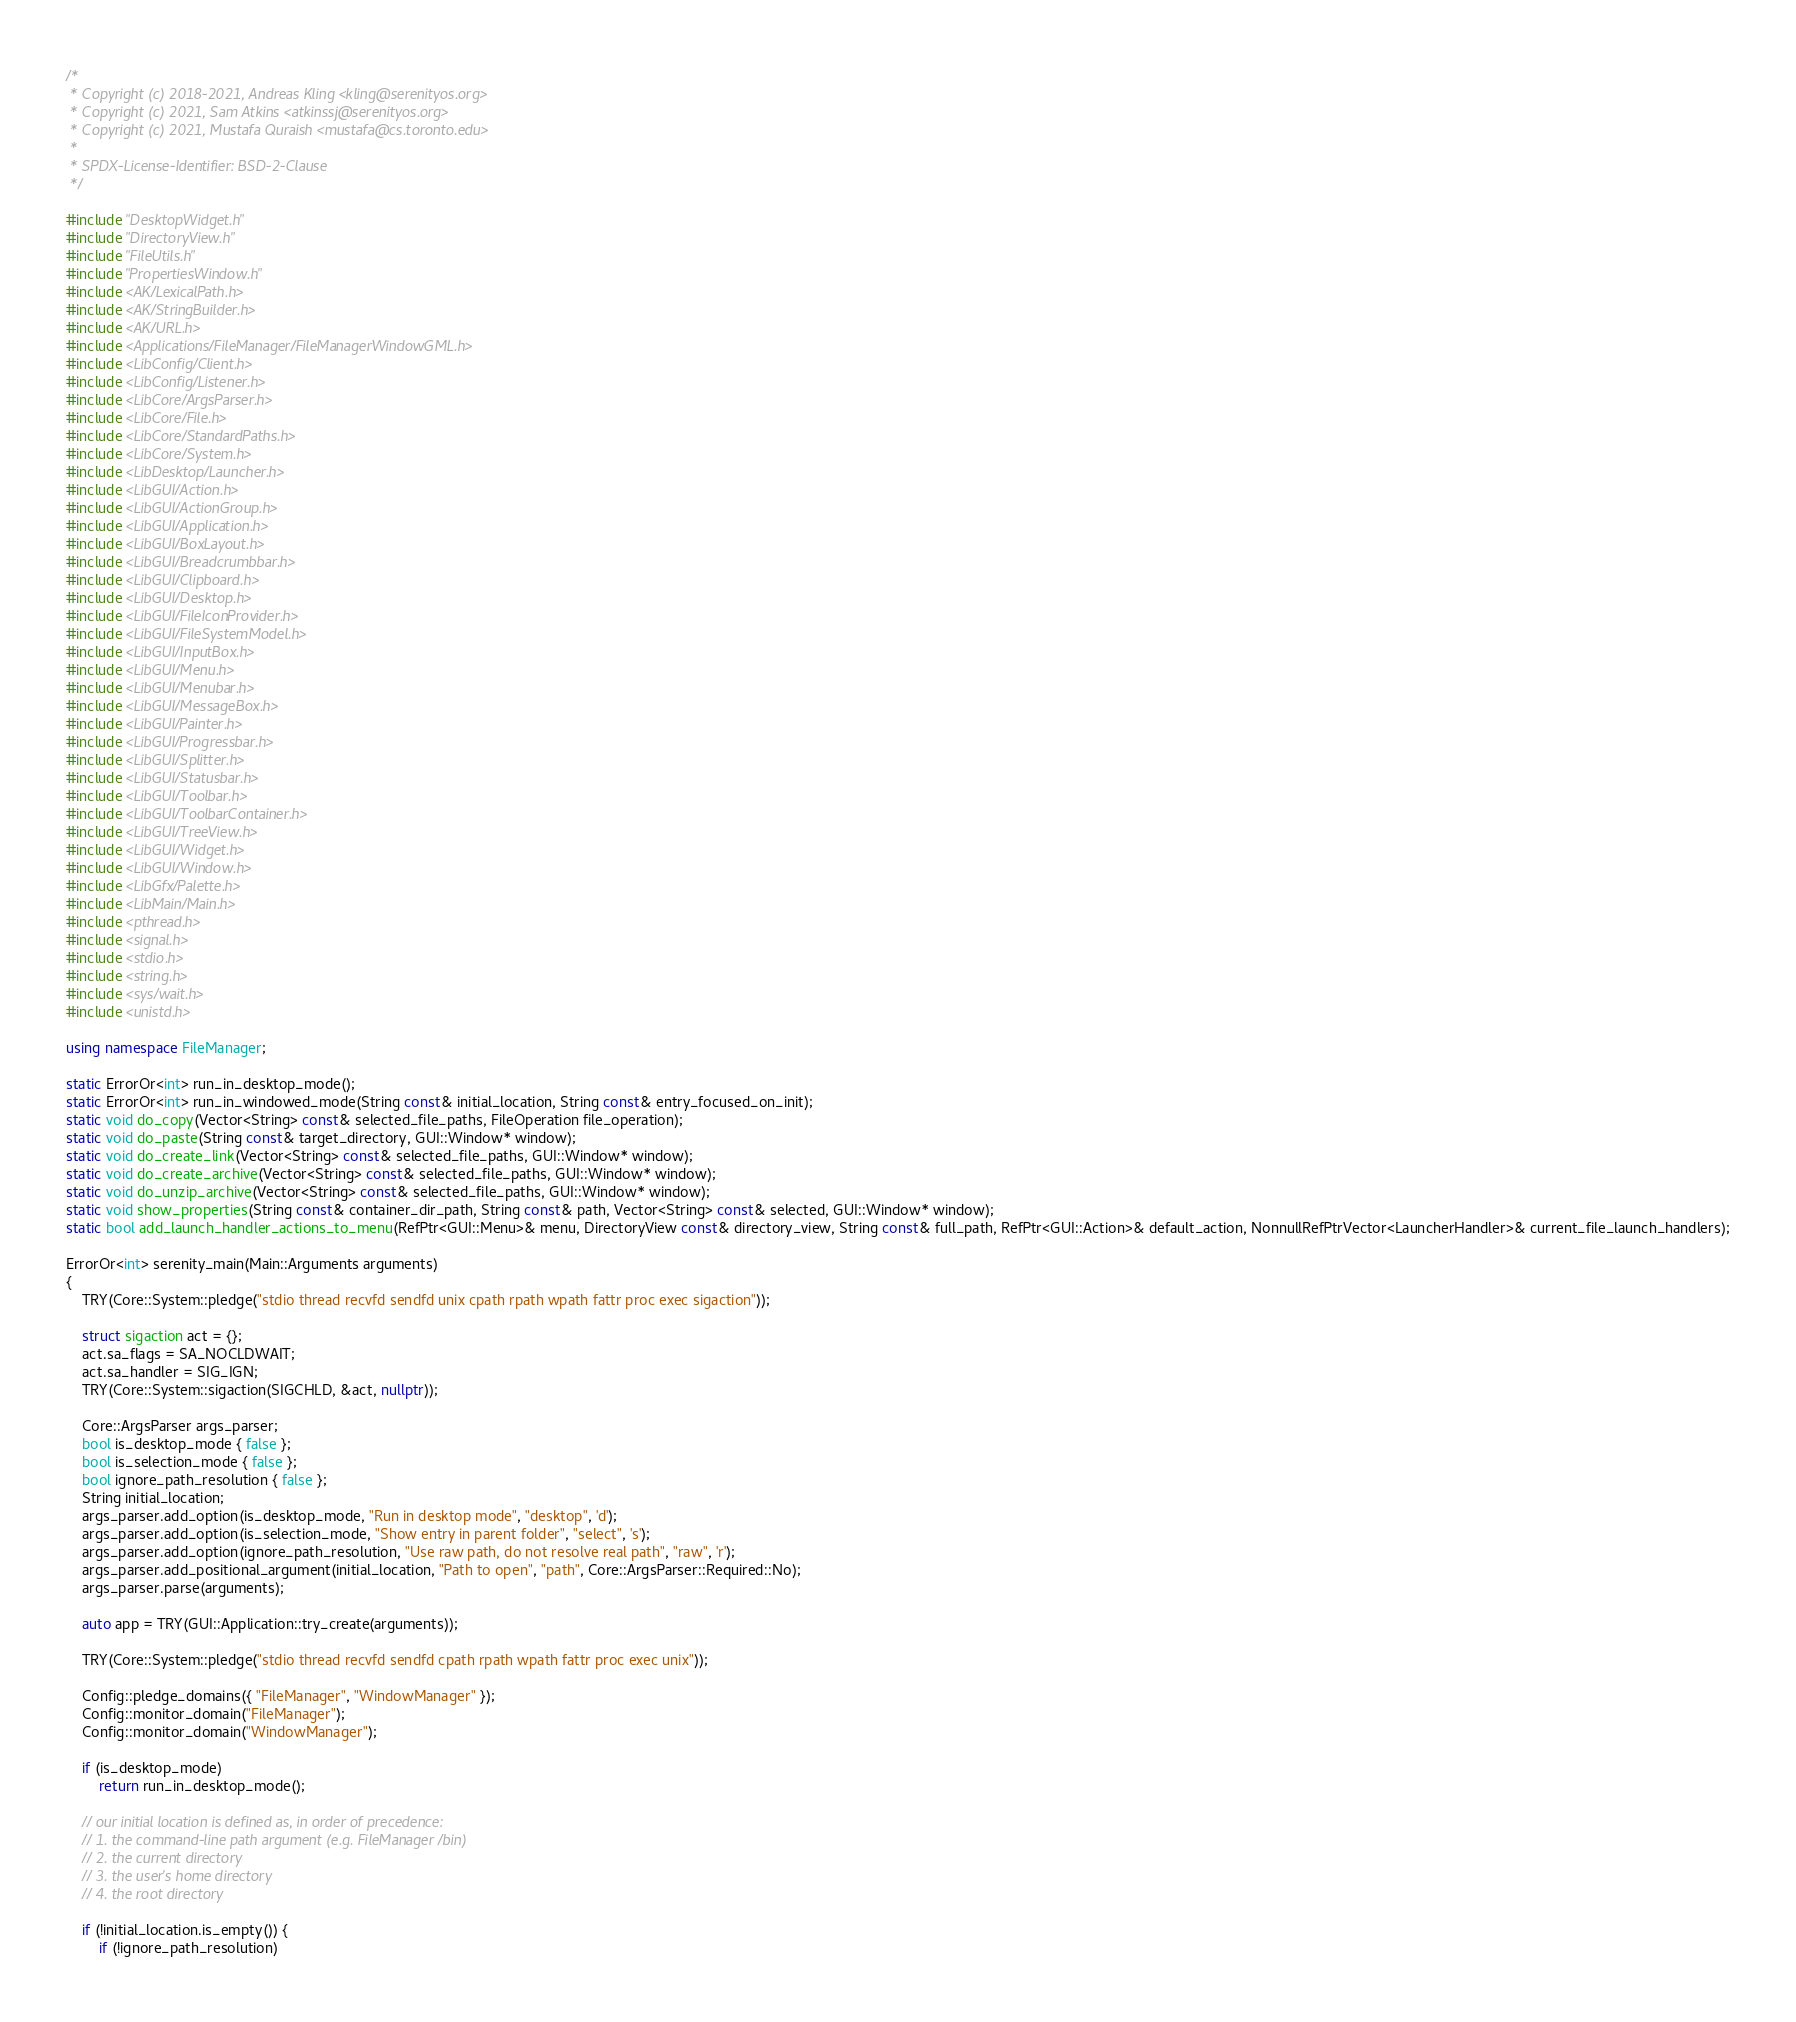Convert code to text. <code><loc_0><loc_0><loc_500><loc_500><_C++_>/*
 * Copyright (c) 2018-2021, Andreas Kling <kling@serenityos.org>
 * Copyright (c) 2021, Sam Atkins <atkinssj@serenityos.org>
 * Copyright (c) 2021, Mustafa Quraish <mustafa@cs.toronto.edu>
 *
 * SPDX-License-Identifier: BSD-2-Clause
 */

#include "DesktopWidget.h"
#include "DirectoryView.h"
#include "FileUtils.h"
#include "PropertiesWindow.h"
#include <AK/LexicalPath.h>
#include <AK/StringBuilder.h>
#include <AK/URL.h>
#include <Applications/FileManager/FileManagerWindowGML.h>
#include <LibConfig/Client.h>
#include <LibConfig/Listener.h>
#include <LibCore/ArgsParser.h>
#include <LibCore/File.h>
#include <LibCore/StandardPaths.h>
#include <LibCore/System.h>
#include <LibDesktop/Launcher.h>
#include <LibGUI/Action.h>
#include <LibGUI/ActionGroup.h>
#include <LibGUI/Application.h>
#include <LibGUI/BoxLayout.h>
#include <LibGUI/Breadcrumbbar.h>
#include <LibGUI/Clipboard.h>
#include <LibGUI/Desktop.h>
#include <LibGUI/FileIconProvider.h>
#include <LibGUI/FileSystemModel.h>
#include <LibGUI/InputBox.h>
#include <LibGUI/Menu.h>
#include <LibGUI/Menubar.h>
#include <LibGUI/MessageBox.h>
#include <LibGUI/Painter.h>
#include <LibGUI/Progressbar.h>
#include <LibGUI/Splitter.h>
#include <LibGUI/Statusbar.h>
#include <LibGUI/Toolbar.h>
#include <LibGUI/ToolbarContainer.h>
#include <LibGUI/TreeView.h>
#include <LibGUI/Widget.h>
#include <LibGUI/Window.h>
#include <LibGfx/Palette.h>
#include <LibMain/Main.h>
#include <pthread.h>
#include <signal.h>
#include <stdio.h>
#include <string.h>
#include <sys/wait.h>
#include <unistd.h>

using namespace FileManager;

static ErrorOr<int> run_in_desktop_mode();
static ErrorOr<int> run_in_windowed_mode(String const& initial_location, String const& entry_focused_on_init);
static void do_copy(Vector<String> const& selected_file_paths, FileOperation file_operation);
static void do_paste(String const& target_directory, GUI::Window* window);
static void do_create_link(Vector<String> const& selected_file_paths, GUI::Window* window);
static void do_create_archive(Vector<String> const& selected_file_paths, GUI::Window* window);
static void do_unzip_archive(Vector<String> const& selected_file_paths, GUI::Window* window);
static void show_properties(String const& container_dir_path, String const& path, Vector<String> const& selected, GUI::Window* window);
static bool add_launch_handler_actions_to_menu(RefPtr<GUI::Menu>& menu, DirectoryView const& directory_view, String const& full_path, RefPtr<GUI::Action>& default_action, NonnullRefPtrVector<LauncherHandler>& current_file_launch_handlers);

ErrorOr<int> serenity_main(Main::Arguments arguments)
{
    TRY(Core::System::pledge("stdio thread recvfd sendfd unix cpath rpath wpath fattr proc exec sigaction"));

    struct sigaction act = {};
    act.sa_flags = SA_NOCLDWAIT;
    act.sa_handler = SIG_IGN;
    TRY(Core::System::sigaction(SIGCHLD, &act, nullptr));

    Core::ArgsParser args_parser;
    bool is_desktop_mode { false };
    bool is_selection_mode { false };
    bool ignore_path_resolution { false };
    String initial_location;
    args_parser.add_option(is_desktop_mode, "Run in desktop mode", "desktop", 'd');
    args_parser.add_option(is_selection_mode, "Show entry in parent folder", "select", 's');
    args_parser.add_option(ignore_path_resolution, "Use raw path, do not resolve real path", "raw", 'r');
    args_parser.add_positional_argument(initial_location, "Path to open", "path", Core::ArgsParser::Required::No);
    args_parser.parse(arguments);

    auto app = TRY(GUI::Application::try_create(arguments));

    TRY(Core::System::pledge("stdio thread recvfd sendfd cpath rpath wpath fattr proc exec unix"));

    Config::pledge_domains({ "FileManager", "WindowManager" });
    Config::monitor_domain("FileManager");
    Config::monitor_domain("WindowManager");

    if (is_desktop_mode)
        return run_in_desktop_mode();

    // our initial location is defined as, in order of precedence:
    // 1. the command-line path argument (e.g. FileManager /bin)
    // 2. the current directory
    // 3. the user's home directory
    // 4. the root directory

    if (!initial_location.is_empty()) {
        if (!ignore_path_resolution)</code> 